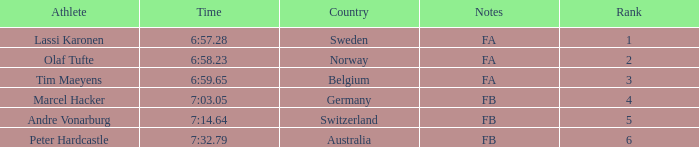What is the lowest rank for Andre Vonarburg, when the notes are FB? 5.0. Could you parse the entire table? {'header': ['Athlete', 'Time', 'Country', 'Notes', 'Rank'], 'rows': [['Lassi Karonen', '6:57.28', 'Sweden', 'FA', '1'], ['Olaf Tufte', '6:58.23', 'Norway', 'FA', '2'], ['Tim Maeyens', '6:59.65', 'Belgium', 'FA', '3'], ['Marcel Hacker', '7:03.05', 'Germany', 'FB', '4'], ['Andre Vonarburg', '7:14.64', 'Switzerland', 'FB', '5'], ['Peter Hardcastle', '7:32.79', 'Australia', 'FB', '6']]} 